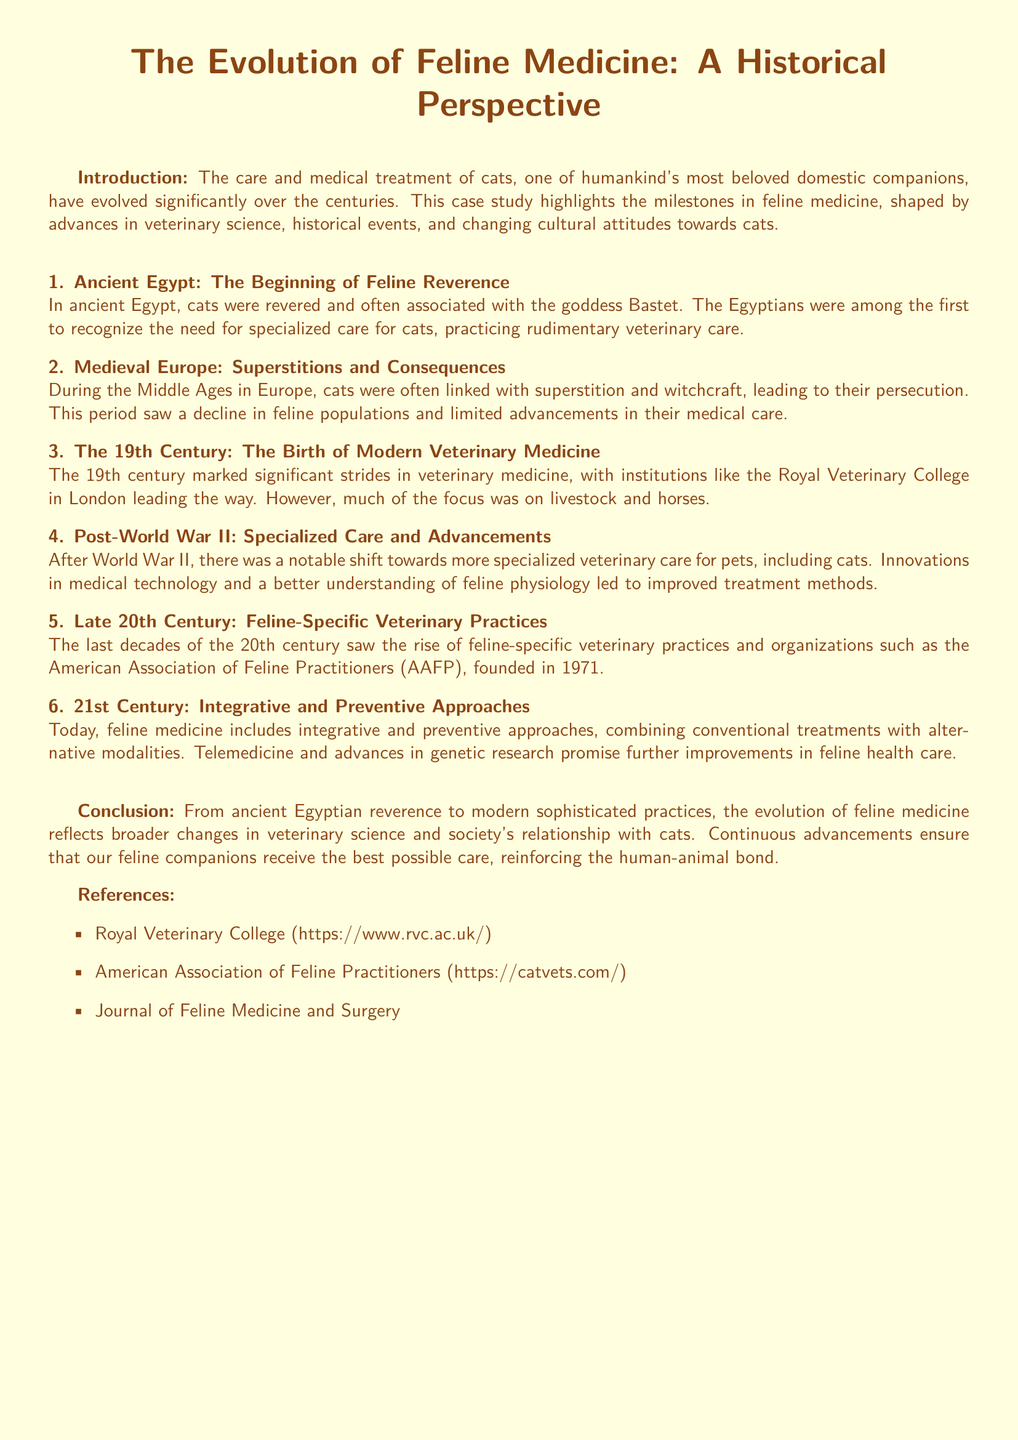What ancient civilization is mentioned in relation to feline medicine? The document states that ancient Egypt recognized the need for specialized care for cats.
Answer: Egypt What organization was founded in 1971? The document mentions the American Association of Feline Practitioners as being founded in this year.
Answer: American Association of Feline Practitioners What marked the birth of modern veterinary medicine? According to the document, the 19th century is marked by significant strides in veterinary medicine.
Answer: 19th century What was a notable shift in veterinary care after World War II? The document highlights a shift towards more specialized veterinary care for pets, including cats.
Answer: Specialized care Which goddess were cats associated with in ancient Egypt? The text indicates that cats were revered and often associated with the goddess Bastet.
Answer: Bastet What approach to feline medicine is emphasized in the 21st century? The document mentions integrative and preventive approaches being included in feline medicine today.
Answer: Integrative and preventive approaches 